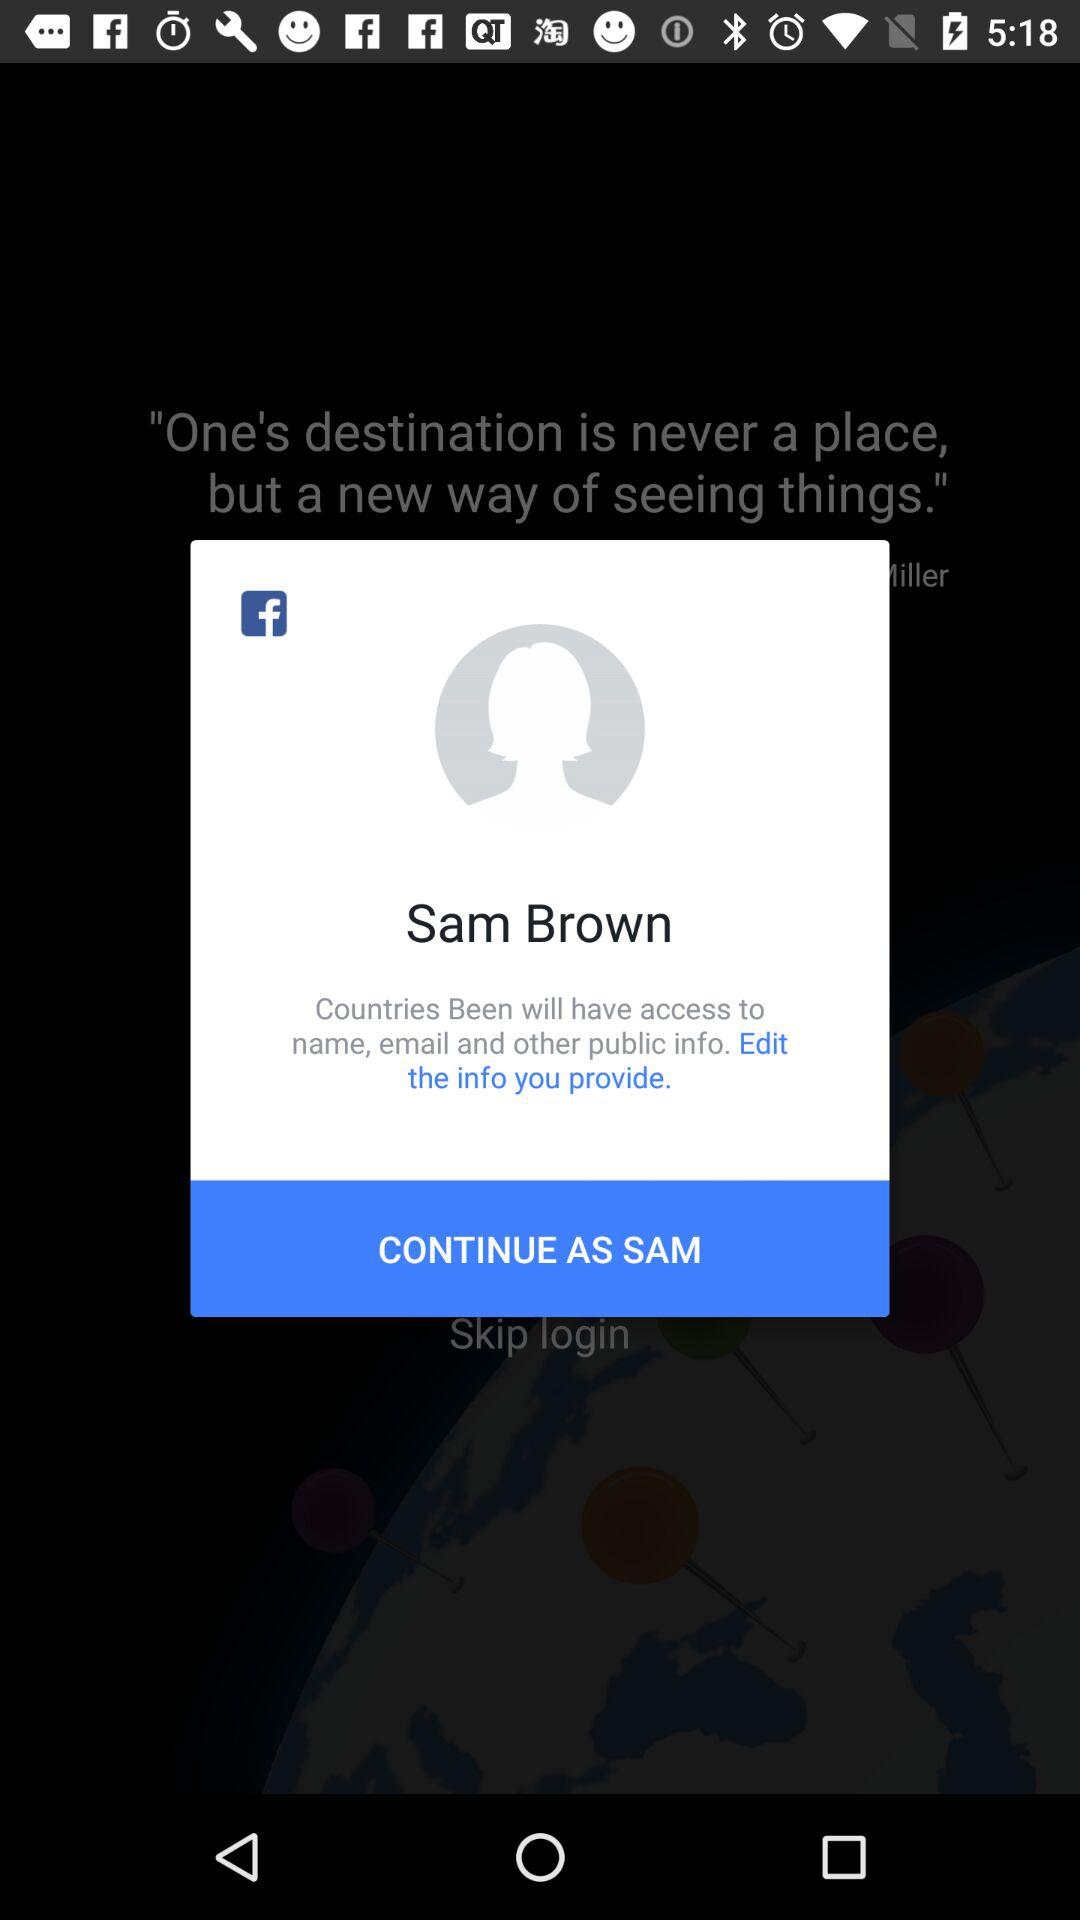What is the login name? The login name is Sam Brown. 